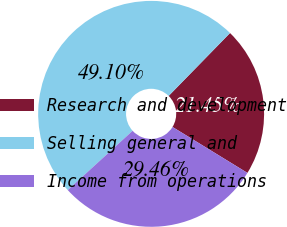Convert chart. <chart><loc_0><loc_0><loc_500><loc_500><pie_chart><fcel>Research and development<fcel>Selling general and<fcel>Income from operations<nl><fcel>21.45%<fcel>49.1%<fcel>29.46%<nl></chart> 